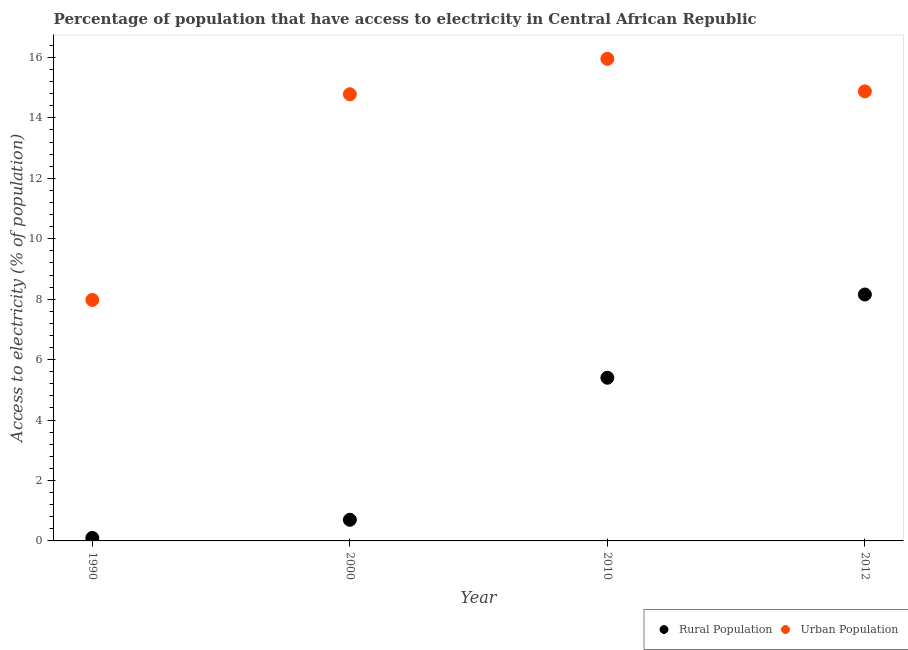Is the number of dotlines equal to the number of legend labels?
Your answer should be very brief. Yes. What is the percentage of urban population having access to electricity in 2012?
Your answer should be compact. 14.88. Across all years, what is the maximum percentage of rural population having access to electricity?
Make the answer very short. 8.15. Across all years, what is the minimum percentage of urban population having access to electricity?
Your answer should be compact. 7.98. In which year was the percentage of urban population having access to electricity minimum?
Offer a very short reply. 1990. What is the total percentage of urban population having access to electricity in the graph?
Your answer should be very brief. 53.59. What is the difference between the percentage of urban population having access to electricity in 2000 and that in 2010?
Offer a terse response. -1.17. What is the difference between the percentage of urban population having access to electricity in 2010 and the percentage of rural population having access to electricity in 2012?
Provide a succinct answer. 7.8. What is the average percentage of urban population having access to electricity per year?
Offer a terse response. 13.4. In the year 2010, what is the difference between the percentage of urban population having access to electricity and percentage of rural population having access to electricity?
Keep it short and to the point. 10.55. What is the ratio of the percentage of urban population having access to electricity in 1990 to that in 2012?
Provide a succinct answer. 0.54. Is the difference between the percentage of urban population having access to electricity in 2000 and 2010 greater than the difference between the percentage of rural population having access to electricity in 2000 and 2010?
Keep it short and to the point. Yes. What is the difference between the highest and the second highest percentage of urban population having access to electricity?
Your response must be concise. 1.08. What is the difference between the highest and the lowest percentage of rural population having access to electricity?
Keep it short and to the point. 8.05. Does the percentage of urban population having access to electricity monotonically increase over the years?
Your response must be concise. No. How many dotlines are there?
Provide a short and direct response. 2. Does the graph contain grids?
Offer a very short reply. No. What is the title of the graph?
Your answer should be compact. Percentage of population that have access to electricity in Central African Republic. What is the label or title of the Y-axis?
Make the answer very short. Access to electricity (% of population). What is the Access to electricity (% of population) of Rural Population in 1990?
Offer a terse response. 0.1. What is the Access to electricity (% of population) of Urban Population in 1990?
Your answer should be very brief. 7.98. What is the Access to electricity (% of population) of Rural Population in 2000?
Keep it short and to the point. 0.7. What is the Access to electricity (% of population) of Urban Population in 2000?
Keep it short and to the point. 14.78. What is the Access to electricity (% of population) in Urban Population in 2010?
Your answer should be compact. 15.95. What is the Access to electricity (% of population) in Rural Population in 2012?
Provide a succinct answer. 8.15. What is the Access to electricity (% of population) of Urban Population in 2012?
Your answer should be very brief. 14.88. Across all years, what is the maximum Access to electricity (% of population) of Rural Population?
Offer a very short reply. 8.15. Across all years, what is the maximum Access to electricity (% of population) of Urban Population?
Your answer should be compact. 15.95. Across all years, what is the minimum Access to electricity (% of population) of Rural Population?
Your answer should be compact. 0.1. Across all years, what is the minimum Access to electricity (% of population) of Urban Population?
Offer a terse response. 7.98. What is the total Access to electricity (% of population) in Rural Population in the graph?
Give a very brief answer. 14.35. What is the total Access to electricity (% of population) in Urban Population in the graph?
Keep it short and to the point. 53.59. What is the difference between the Access to electricity (% of population) of Urban Population in 1990 and that in 2000?
Give a very brief answer. -6.81. What is the difference between the Access to electricity (% of population) in Rural Population in 1990 and that in 2010?
Provide a short and direct response. -5.3. What is the difference between the Access to electricity (% of population) of Urban Population in 1990 and that in 2010?
Offer a terse response. -7.98. What is the difference between the Access to electricity (% of population) in Rural Population in 1990 and that in 2012?
Keep it short and to the point. -8.05. What is the difference between the Access to electricity (% of population) in Urban Population in 1990 and that in 2012?
Make the answer very short. -6.9. What is the difference between the Access to electricity (% of population) in Rural Population in 2000 and that in 2010?
Provide a short and direct response. -4.7. What is the difference between the Access to electricity (% of population) of Urban Population in 2000 and that in 2010?
Provide a short and direct response. -1.17. What is the difference between the Access to electricity (% of population) of Rural Population in 2000 and that in 2012?
Give a very brief answer. -7.45. What is the difference between the Access to electricity (% of population) in Urban Population in 2000 and that in 2012?
Provide a short and direct response. -0.1. What is the difference between the Access to electricity (% of population) in Rural Population in 2010 and that in 2012?
Provide a succinct answer. -2.75. What is the difference between the Access to electricity (% of population) in Urban Population in 2010 and that in 2012?
Provide a succinct answer. 1.08. What is the difference between the Access to electricity (% of population) in Rural Population in 1990 and the Access to electricity (% of population) in Urban Population in 2000?
Give a very brief answer. -14.68. What is the difference between the Access to electricity (% of population) in Rural Population in 1990 and the Access to electricity (% of population) in Urban Population in 2010?
Your answer should be very brief. -15.85. What is the difference between the Access to electricity (% of population) in Rural Population in 1990 and the Access to electricity (% of population) in Urban Population in 2012?
Your response must be concise. -14.78. What is the difference between the Access to electricity (% of population) of Rural Population in 2000 and the Access to electricity (% of population) of Urban Population in 2010?
Offer a very short reply. -15.25. What is the difference between the Access to electricity (% of population) in Rural Population in 2000 and the Access to electricity (% of population) in Urban Population in 2012?
Your answer should be compact. -14.18. What is the difference between the Access to electricity (% of population) in Rural Population in 2010 and the Access to electricity (% of population) in Urban Population in 2012?
Offer a very short reply. -9.48. What is the average Access to electricity (% of population) in Rural Population per year?
Provide a short and direct response. 3.59. What is the average Access to electricity (% of population) of Urban Population per year?
Offer a terse response. 13.4. In the year 1990, what is the difference between the Access to electricity (% of population) in Rural Population and Access to electricity (% of population) in Urban Population?
Provide a short and direct response. -7.88. In the year 2000, what is the difference between the Access to electricity (% of population) of Rural Population and Access to electricity (% of population) of Urban Population?
Make the answer very short. -14.08. In the year 2010, what is the difference between the Access to electricity (% of population) in Rural Population and Access to electricity (% of population) in Urban Population?
Provide a short and direct response. -10.55. In the year 2012, what is the difference between the Access to electricity (% of population) in Rural Population and Access to electricity (% of population) in Urban Population?
Offer a very short reply. -6.72. What is the ratio of the Access to electricity (% of population) of Rural Population in 1990 to that in 2000?
Give a very brief answer. 0.14. What is the ratio of the Access to electricity (% of population) of Urban Population in 1990 to that in 2000?
Ensure brevity in your answer.  0.54. What is the ratio of the Access to electricity (% of population) of Rural Population in 1990 to that in 2010?
Your answer should be compact. 0.02. What is the ratio of the Access to electricity (% of population) in Urban Population in 1990 to that in 2010?
Give a very brief answer. 0.5. What is the ratio of the Access to electricity (% of population) of Rural Population in 1990 to that in 2012?
Offer a terse response. 0.01. What is the ratio of the Access to electricity (% of population) in Urban Population in 1990 to that in 2012?
Keep it short and to the point. 0.54. What is the ratio of the Access to electricity (% of population) in Rural Population in 2000 to that in 2010?
Provide a short and direct response. 0.13. What is the ratio of the Access to electricity (% of population) of Urban Population in 2000 to that in 2010?
Ensure brevity in your answer.  0.93. What is the ratio of the Access to electricity (% of population) in Rural Population in 2000 to that in 2012?
Your response must be concise. 0.09. What is the ratio of the Access to electricity (% of population) of Urban Population in 2000 to that in 2012?
Ensure brevity in your answer.  0.99. What is the ratio of the Access to electricity (% of population) in Rural Population in 2010 to that in 2012?
Offer a terse response. 0.66. What is the ratio of the Access to electricity (% of population) of Urban Population in 2010 to that in 2012?
Your response must be concise. 1.07. What is the difference between the highest and the second highest Access to electricity (% of population) in Rural Population?
Give a very brief answer. 2.75. What is the difference between the highest and the second highest Access to electricity (% of population) in Urban Population?
Offer a terse response. 1.08. What is the difference between the highest and the lowest Access to electricity (% of population) of Rural Population?
Make the answer very short. 8.05. What is the difference between the highest and the lowest Access to electricity (% of population) in Urban Population?
Keep it short and to the point. 7.98. 